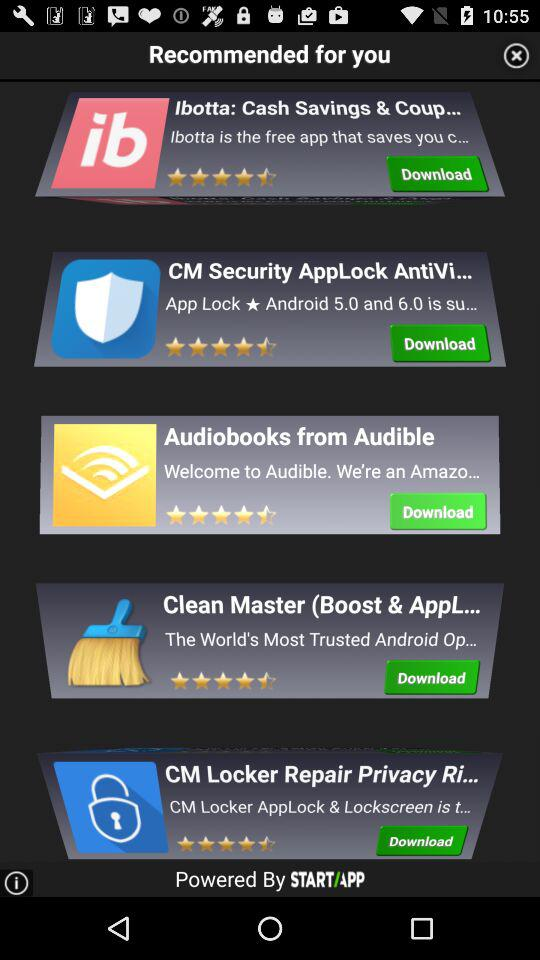What is the star rating for the application "Audiobooks from Audible"? The star rating for the application "Audiobooks from Audible" is 4.5 stars. 